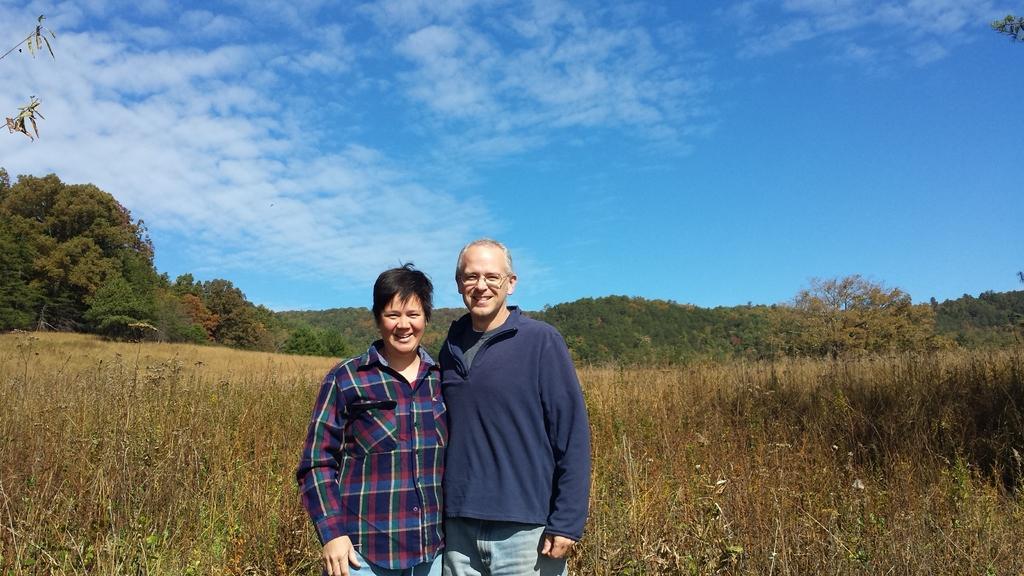In one or two sentences, can you explain what this image depicts? In this image we can see two persons standing and smiling, behind them, we can see some plants and trees, in the background we can see the sky with clouds. 